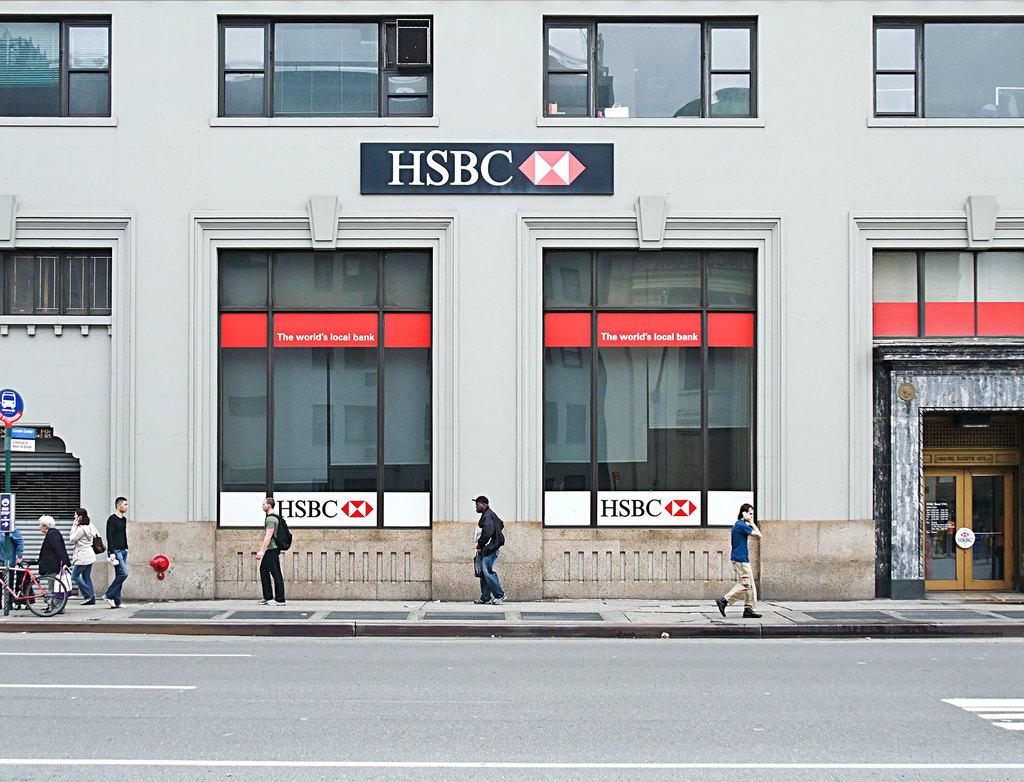Is hsbc plastered on this building?
Your response must be concise. Yes. 